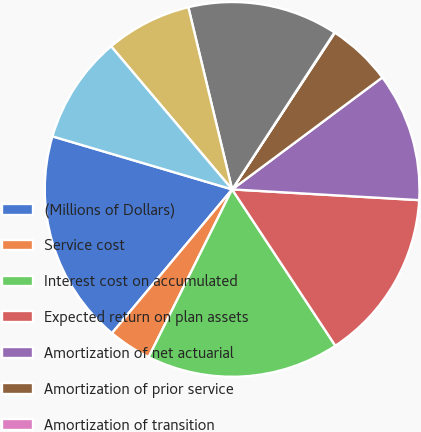Convert chart. <chart><loc_0><loc_0><loc_500><loc_500><pie_chart><fcel>(Millions of Dollars)<fcel>Service cost<fcel>Interest cost on accumulated<fcel>Expected return on plan assets<fcel>Amortization of net actuarial<fcel>Amortization of prior service<fcel>Amortization of transition<fcel>Net Periodic Postretirement<fcel>Cost capitalized<fcel>Cost deferred<nl><fcel>18.49%<fcel>3.73%<fcel>16.64%<fcel>14.8%<fcel>11.11%<fcel>5.57%<fcel>0.04%<fcel>12.95%<fcel>7.42%<fcel>9.26%<nl></chart> 